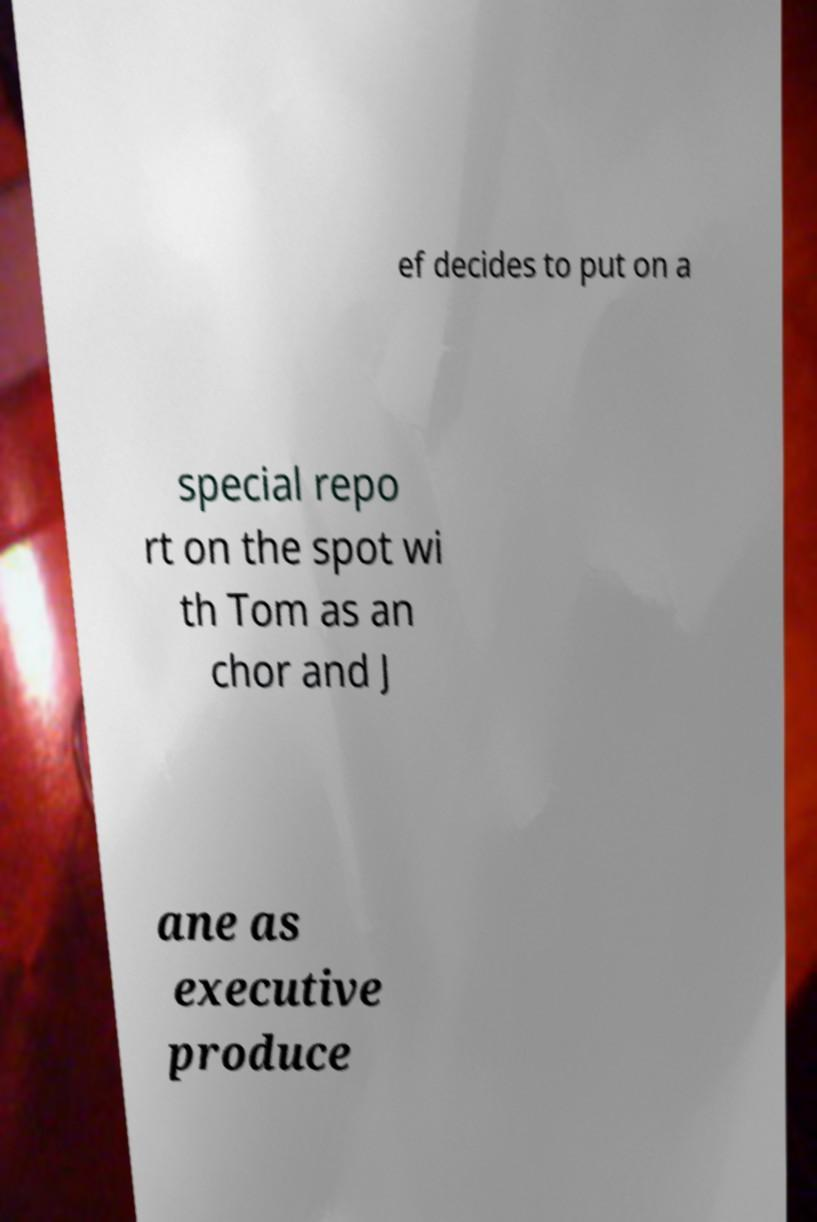Could you extract and type out the text from this image? ef decides to put on a special repo rt on the spot wi th Tom as an chor and J ane as executive produce 